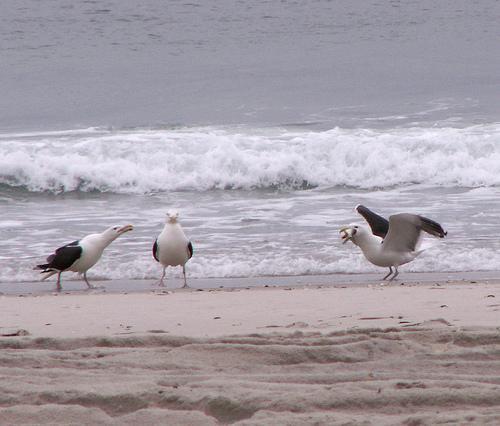How many birds have their wings lifted?
Give a very brief answer. 1. How many bird legs are visible?
Give a very brief answer. 6. How many birds can you see?
Give a very brief answer. 3. 